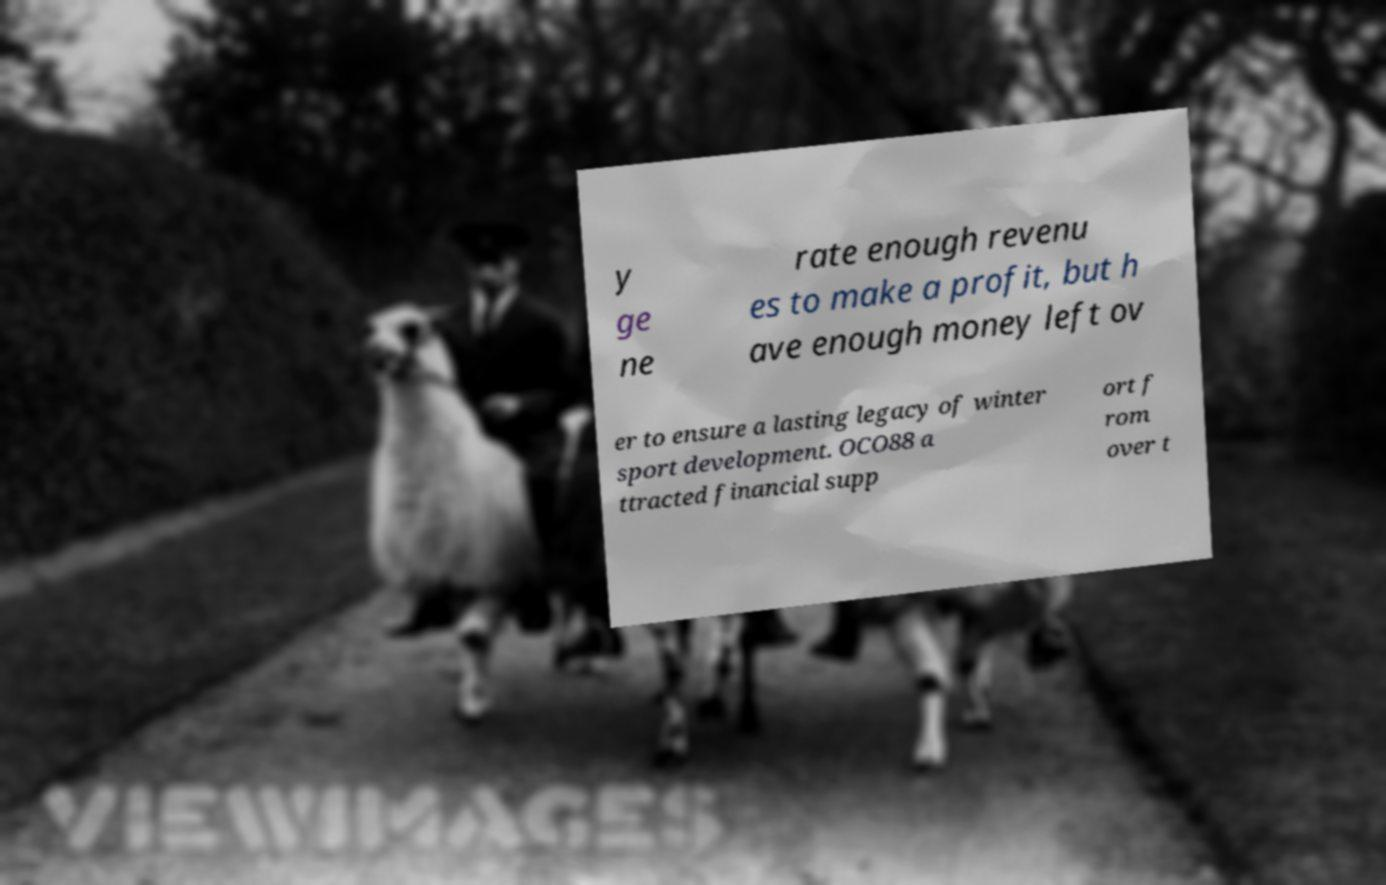Could you extract and type out the text from this image? y ge ne rate enough revenu es to make a profit, but h ave enough money left ov er to ensure a lasting legacy of winter sport development. OCO88 a ttracted financial supp ort f rom over t 